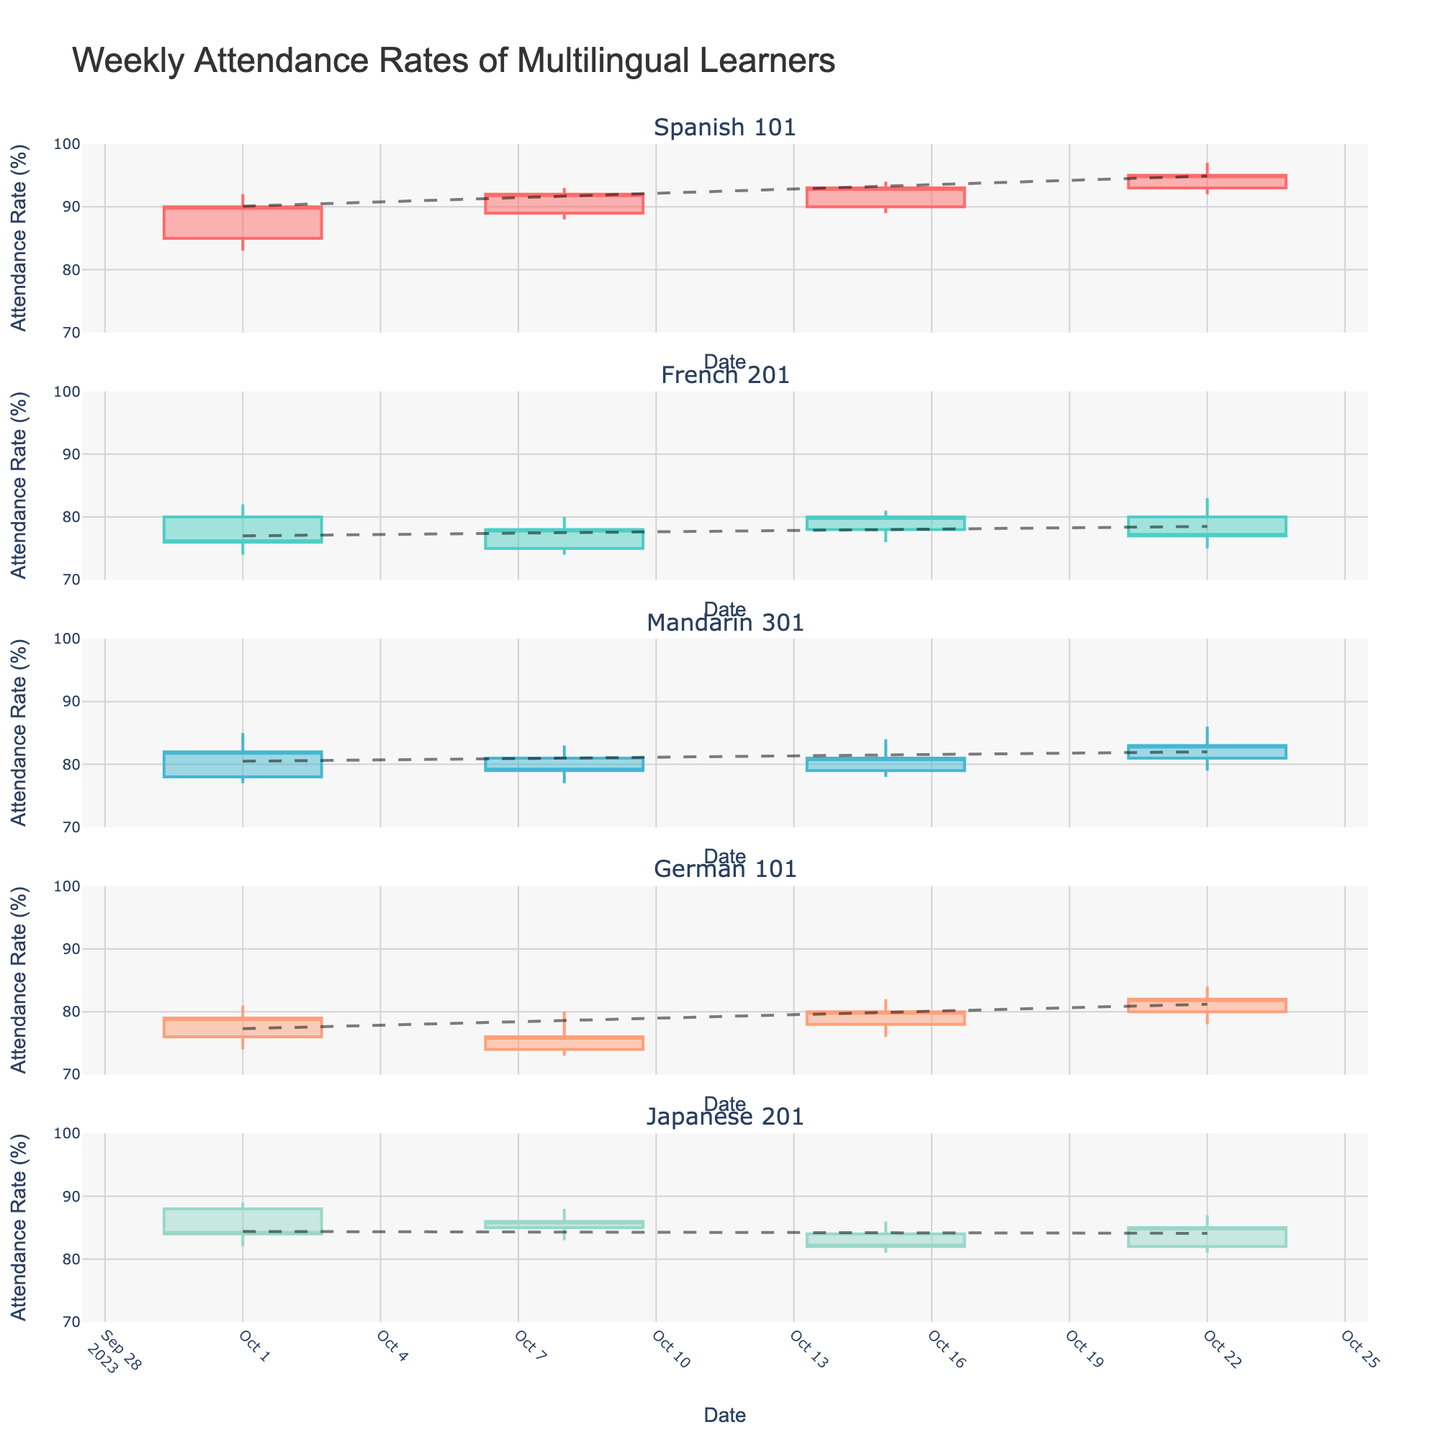What's the title of the figure? The title of the figure is located at the top and is formatted in large text.
Answer: Weekly Attendance Rates of Multilingual Learners What are the names of the classes represented in the figure? The subplot titles for each class are in the middle-left of each subplot. They are labeled individually for each candlestick section.
Answer: Spanish 101, French 201, Mandarin 301, German 101, Japanese 201 Which class had the highest attendance rate on October 15? Look at the candlestick representing October 15 for each class. The attendance rate is represented by the "High" values of each candlestick.
Answer: Spanish 101 On which date did Japanese 201 experience the lowest attendance rate? Identify the candlestick with the lowest "Low" value within the Japanese 201 subplot. Read the corresponding date along the x-axis.
Answer: October 01 What's the trend direction for French 201's attendance over time? Examine the trend line added for the French 201 subplot. If it ascends from left to right, the trend is increasing; if it descends, the trend is decreasing.
Answer: Decreasing Compare the attendance rates of German 101 and Mandarin 301 on October 22. Which had a higher closing attendance rate? Identify the candlesticks for October 22 in both the German 101 and Mandarin 301 subplots. The "Close" value indicates the closing attendance rate.
Answer: Mandarin 301 What is the overall range of attendance rates for Spanish 101 across all dates? Identify the highest "High" value and the lowest "Low" value of all candlesticks in the Spanish 101 subplot. Subtract the lowest value from the highest.
Answer: 97 - 83 = 14 On which date did French 201 see a significant drop in attendance? Look for the candlestick in French 201 where the "Open" is much higher than the "Close". Observe the corresponding date.
Answer: October 01 What is the average closing attendance rate of Japanese 201 over the four weeks? Identify the "Close" values for all dates in the Japanese 201 subplot. Add them up and divide by 4.
Answer: (84 + 86 + 82 + 85) / 4 = 84.25 Did Spanish 101 have an increasing or decreasing attendance trend? Check the trend line added to the Spanish 101 subplot. An ascending line indicates an increasing trend.
Answer: Increasing 